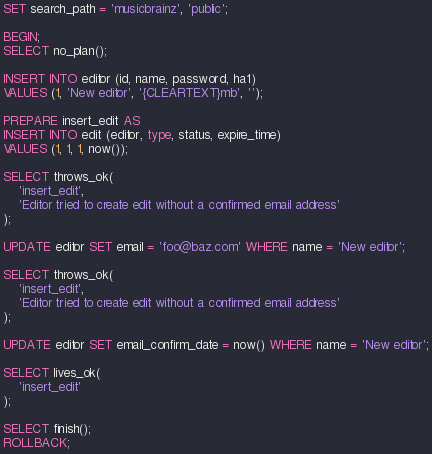<code> <loc_0><loc_0><loc_500><loc_500><_SQL_>SET search_path = 'musicbrainz', 'public';

BEGIN;
SELECT no_plan();

INSERT INTO editor (id, name, password, ha1)
VALUES (1, 'New editor', '{CLEARTEXT}mb', '');

PREPARE insert_edit AS
INSERT INTO edit (editor, type, status, expire_time)
VALUES (1, 1, 1, now());

SELECT throws_ok(
    'insert_edit',
    'Editor tried to create edit without a confirmed email address'
);

UPDATE editor SET email = 'foo@baz.com' WHERE name = 'New editor';

SELECT throws_ok(
    'insert_edit',
    'Editor tried to create edit without a confirmed email address'
);

UPDATE editor SET email_confirm_date = now() WHERE name = 'New editor';

SELECT lives_ok(
    'insert_edit'
);

SELECT finish();
ROLLBACK;
</code> 